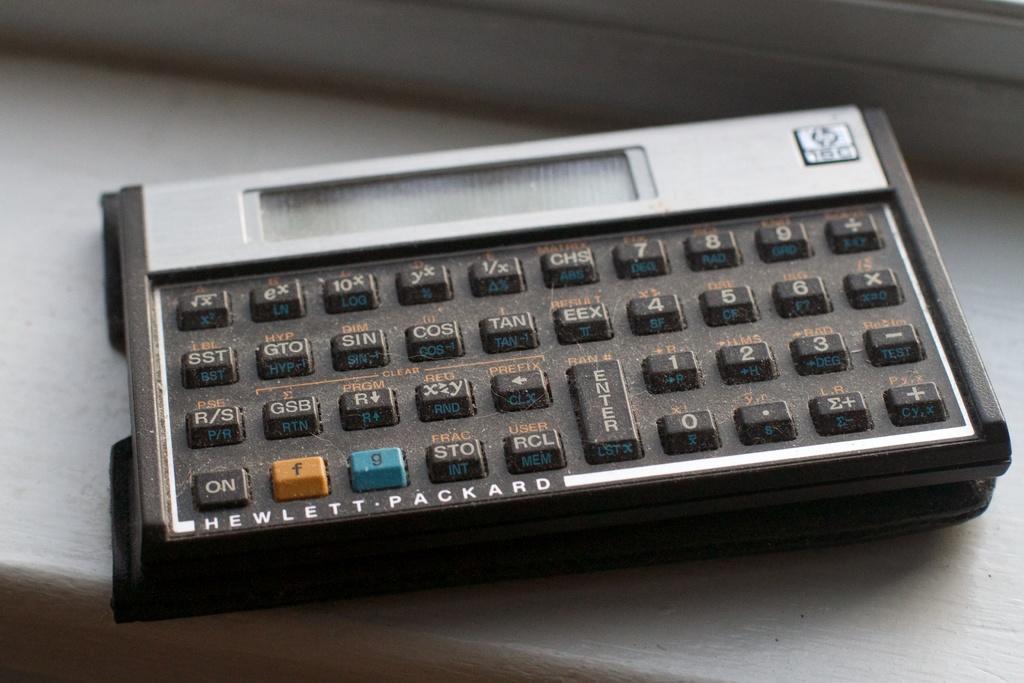What brand is the machine?
Your response must be concise. Hewlett packard. What do you do with the large key?
Make the answer very short. Enter. 